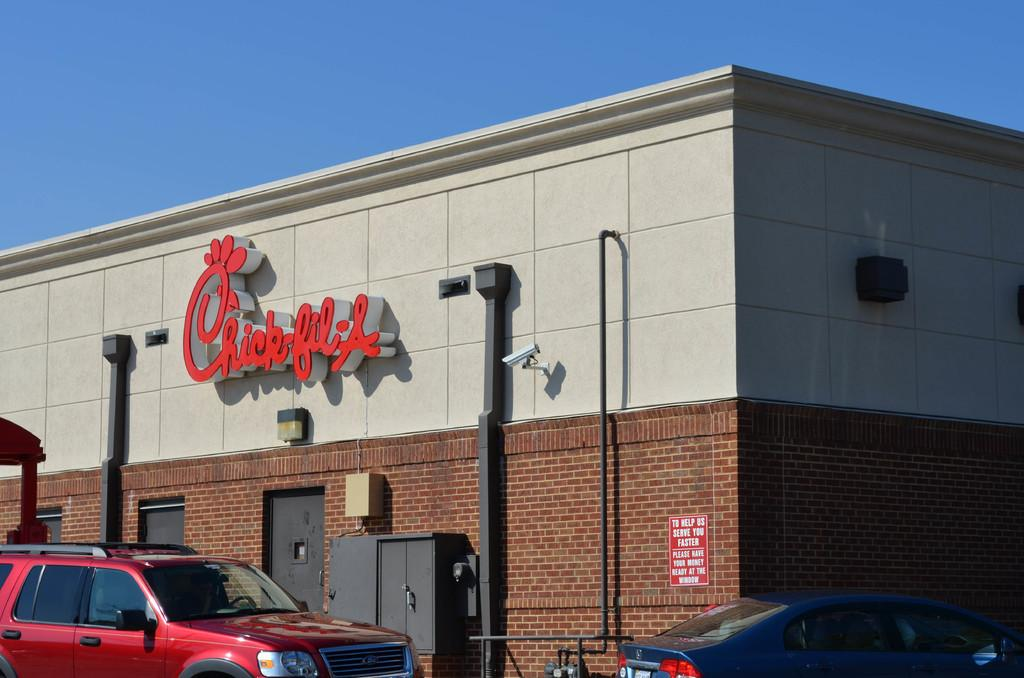What is the main subject of the image? The main subject of the image is cars. How are the cars positioned in the image? The cars are in front of other elements in the image. What is located behind the cars in the image? There is a building behind the cars. What can be seen in the background of the image? The sky is visible in the background of the image. Is there a spark visible between the cars in the image? There is no spark visible between the cars in the image. 